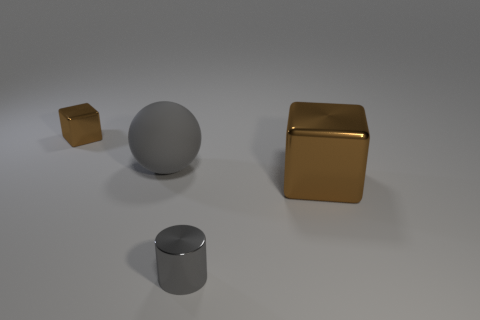How many things are tiny gray shiny things or tiny shiny things that are in front of the small metal block?
Your answer should be very brief. 1. Is the number of large brown things less than the number of large things?
Make the answer very short. Yes. There is a tiny metal thing to the right of the brown thing behind the metallic block to the right of the tiny gray metallic thing; what is its color?
Make the answer very short. Gray. Is the material of the large brown thing the same as the small cylinder?
Provide a succinct answer. Yes. There is a matte ball; what number of shiny things are in front of it?
Give a very brief answer. 2. What is the size of the other thing that is the same shape as the large brown object?
Ensure brevity in your answer.  Small. How many purple things are matte balls or cubes?
Your response must be concise. 0. There is a brown metallic cube that is in front of the tiny brown metallic object; how many big matte things are left of it?
Ensure brevity in your answer.  1. What number of other objects are the same shape as the big rubber object?
Ensure brevity in your answer.  0. What is the material of the big thing that is the same color as the small cylinder?
Keep it short and to the point. Rubber. 